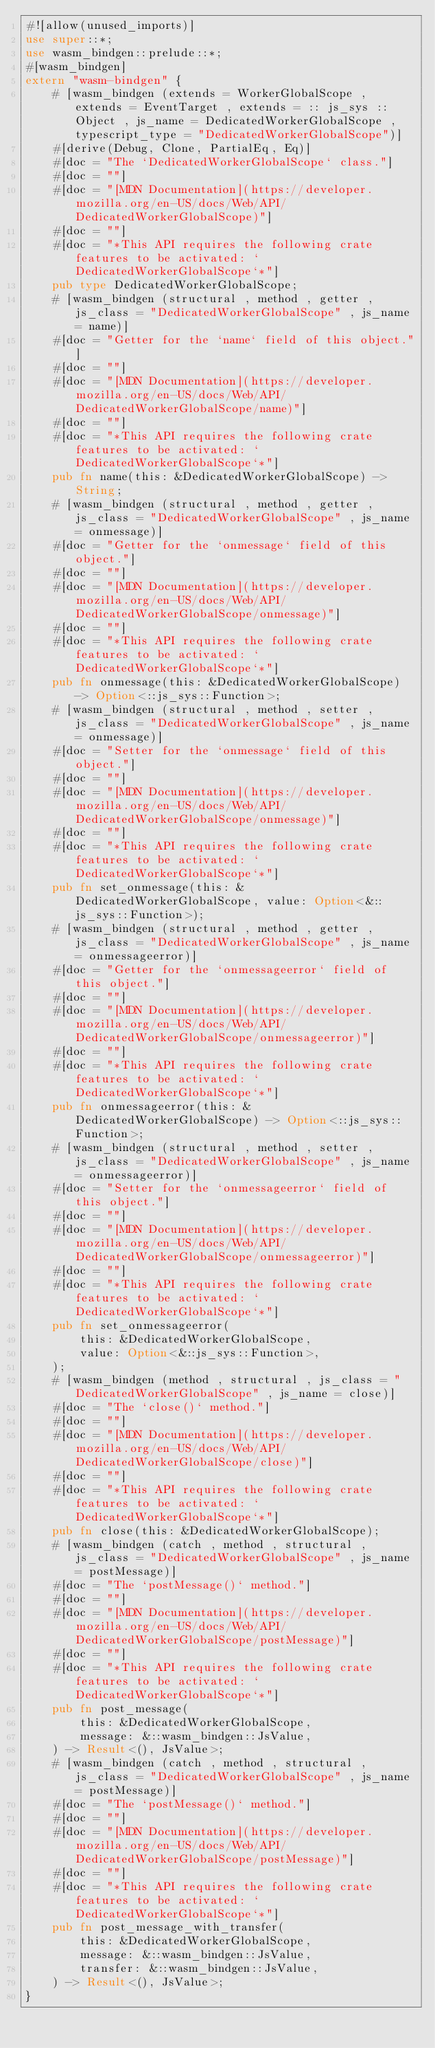<code> <loc_0><loc_0><loc_500><loc_500><_Rust_>#![allow(unused_imports)]
use super::*;
use wasm_bindgen::prelude::*;
#[wasm_bindgen]
extern "wasm-bindgen" {
    # [wasm_bindgen (extends = WorkerGlobalScope , extends = EventTarget , extends = :: js_sys :: Object , js_name = DedicatedWorkerGlobalScope , typescript_type = "DedicatedWorkerGlobalScope")]
    #[derive(Debug, Clone, PartialEq, Eq)]
    #[doc = "The `DedicatedWorkerGlobalScope` class."]
    #[doc = ""]
    #[doc = "[MDN Documentation](https://developer.mozilla.org/en-US/docs/Web/API/DedicatedWorkerGlobalScope)"]
    #[doc = ""]
    #[doc = "*This API requires the following crate features to be activated: `DedicatedWorkerGlobalScope`*"]
    pub type DedicatedWorkerGlobalScope;
    # [wasm_bindgen (structural , method , getter , js_class = "DedicatedWorkerGlobalScope" , js_name = name)]
    #[doc = "Getter for the `name` field of this object."]
    #[doc = ""]
    #[doc = "[MDN Documentation](https://developer.mozilla.org/en-US/docs/Web/API/DedicatedWorkerGlobalScope/name)"]
    #[doc = ""]
    #[doc = "*This API requires the following crate features to be activated: `DedicatedWorkerGlobalScope`*"]
    pub fn name(this: &DedicatedWorkerGlobalScope) -> String;
    # [wasm_bindgen (structural , method , getter , js_class = "DedicatedWorkerGlobalScope" , js_name = onmessage)]
    #[doc = "Getter for the `onmessage` field of this object."]
    #[doc = ""]
    #[doc = "[MDN Documentation](https://developer.mozilla.org/en-US/docs/Web/API/DedicatedWorkerGlobalScope/onmessage)"]
    #[doc = ""]
    #[doc = "*This API requires the following crate features to be activated: `DedicatedWorkerGlobalScope`*"]
    pub fn onmessage(this: &DedicatedWorkerGlobalScope) -> Option<::js_sys::Function>;
    # [wasm_bindgen (structural , method , setter , js_class = "DedicatedWorkerGlobalScope" , js_name = onmessage)]
    #[doc = "Setter for the `onmessage` field of this object."]
    #[doc = ""]
    #[doc = "[MDN Documentation](https://developer.mozilla.org/en-US/docs/Web/API/DedicatedWorkerGlobalScope/onmessage)"]
    #[doc = ""]
    #[doc = "*This API requires the following crate features to be activated: `DedicatedWorkerGlobalScope`*"]
    pub fn set_onmessage(this: &DedicatedWorkerGlobalScope, value: Option<&::js_sys::Function>);
    # [wasm_bindgen (structural , method , getter , js_class = "DedicatedWorkerGlobalScope" , js_name = onmessageerror)]
    #[doc = "Getter for the `onmessageerror` field of this object."]
    #[doc = ""]
    #[doc = "[MDN Documentation](https://developer.mozilla.org/en-US/docs/Web/API/DedicatedWorkerGlobalScope/onmessageerror)"]
    #[doc = ""]
    #[doc = "*This API requires the following crate features to be activated: `DedicatedWorkerGlobalScope`*"]
    pub fn onmessageerror(this: &DedicatedWorkerGlobalScope) -> Option<::js_sys::Function>;
    # [wasm_bindgen (structural , method , setter , js_class = "DedicatedWorkerGlobalScope" , js_name = onmessageerror)]
    #[doc = "Setter for the `onmessageerror` field of this object."]
    #[doc = ""]
    #[doc = "[MDN Documentation](https://developer.mozilla.org/en-US/docs/Web/API/DedicatedWorkerGlobalScope/onmessageerror)"]
    #[doc = ""]
    #[doc = "*This API requires the following crate features to be activated: `DedicatedWorkerGlobalScope`*"]
    pub fn set_onmessageerror(
        this: &DedicatedWorkerGlobalScope,
        value: Option<&::js_sys::Function>,
    );
    # [wasm_bindgen (method , structural , js_class = "DedicatedWorkerGlobalScope" , js_name = close)]
    #[doc = "The `close()` method."]
    #[doc = ""]
    #[doc = "[MDN Documentation](https://developer.mozilla.org/en-US/docs/Web/API/DedicatedWorkerGlobalScope/close)"]
    #[doc = ""]
    #[doc = "*This API requires the following crate features to be activated: `DedicatedWorkerGlobalScope`*"]
    pub fn close(this: &DedicatedWorkerGlobalScope);
    # [wasm_bindgen (catch , method , structural , js_class = "DedicatedWorkerGlobalScope" , js_name = postMessage)]
    #[doc = "The `postMessage()` method."]
    #[doc = ""]
    #[doc = "[MDN Documentation](https://developer.mozilla.org/en-US/docs/Web/API/DedicatedWorkerGlobalScope/postMessage)"]
    #[doc = ""]
    #[doc = "*This API requires the following crate features to be activated: `DedicatedWorkerGlobalScope`*"]
    pub fn post_message(
        this: &DedicatedWorkerGlobalScope,
        message: &::wasm_bindgen::JsValue,
    ) -> Result<(), JsValue>;
    # [wasm_bindgen (catch , method , structural , js_class = "DedicatedWorkerGlobalScope" , js_name = postMessage)]
    #[doc = "The `postMessage()` method."]
    #[doc = ""]
    #[doc = "[MDN Documentation](https://developer.mozilla.org/en-US/docs/Web/API/DedicatedWorkerGlobalScope/postMessage)"]
    #[doc = ""]
    #[doc = "*This API requires the following crate features to be activated: `DedicatedWorkerGlobalScope`*"]
    pub fn post_message_with_transfer(
        this: &DedicatedWorkerGlobalScope,
        message: &::wasm_bindgen::JsValue,
        transfer: &::wasm_bindgen::JsValue,
    ) -> Result<(), JsValue>;
}
</code> 